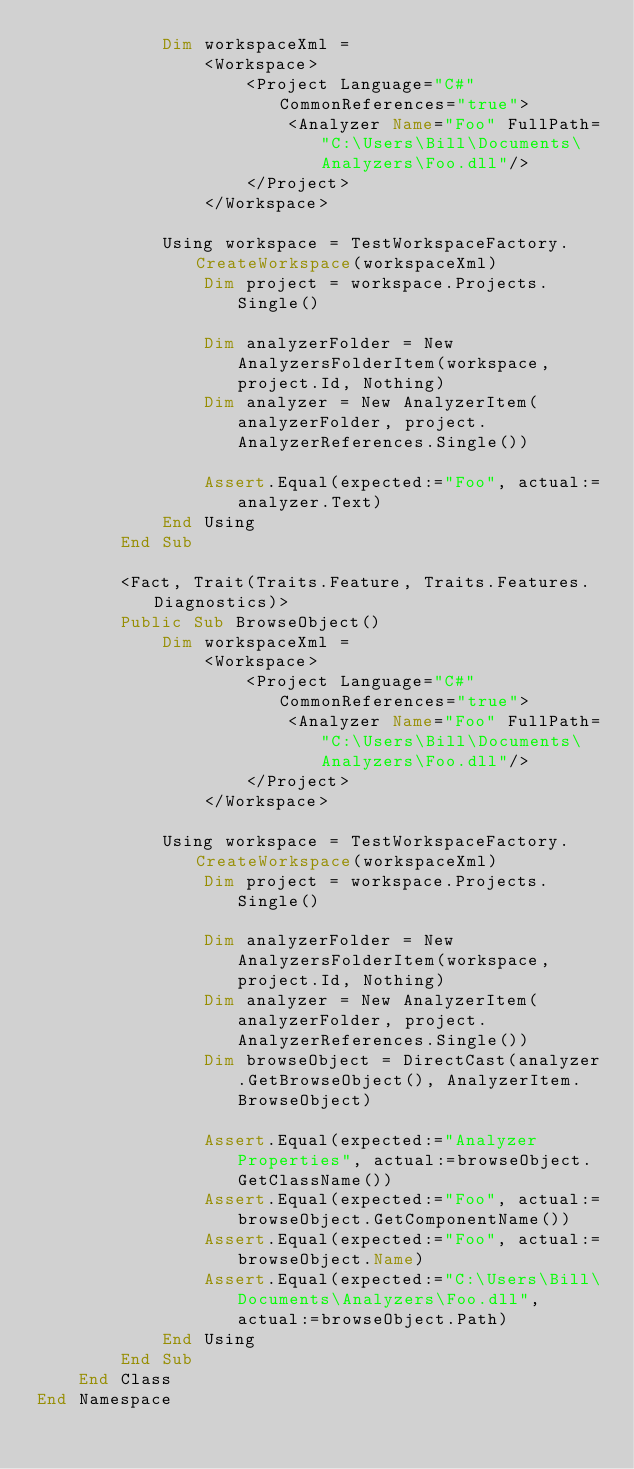Convert code to text. <code><loc_0><loc_0><loc_500><loc_500><_VisualBasic_>            Dim workspaceXml =
                <Workspace>
                    <Project Language="C#" CommonReferences="true">
                        <Analyzer Name="Foo" FullPath="C:\Users\Bill\Documents\Analyzers\Foo.dll"/>
                    </Project>
                </Workspace>

            Using workspace = TestWorkspaceFactory.CreateWorkspace(workspaceXml)
                Dim project = workspace.Projects.Single()

                Dim analyzerFolder = New AnalyzersFolderItem(workspace, project.Id, Nothing)
                Dim analyzer = New AnalyzerItem(analyzerFolder, project.AnalyzerReferences.Single())

                Assert.Equal(expected:="Foo", actual:=analyzer.Text)
            End Using
        End Sub

        <Fact, Trait(Traits.Feature, Traits.Features.Diagnostics)>
        Public Sub BrowseObject()
            Dim workspaceXml =
                <Workspace>
                    <Project Language="C#" CommonReferences="true">
                        <Analyzer Name="Foo" FullPath="C:\Users\Bill\Documents\Analyzers\Foo.dll"/>
                    </Project>
                </Workspace>

            Using workspace = TestWorkspaceFactory.CreateWorkspace(workspaceXml)
                Dim project = workspace.Projects.Single()

                Dim analyzerFolder = New AnalyzersFolderItem(workspace, project.Id, Nothing)
                Dim analyzer = New AnalyzerItem(analyzerFolder, project.AnalyzerReferences.Single())
                Dim browseObject = DirectCast(analyzer.GetBrowseObject(), AnalyzerItem.BrowseObject)

                Assert.Equal(expected:="Analyzer Properties", actual:=browseObject.GetClassName())
                Assert.Equal(expected:="Foo", actual:=browseObject.GetComponentName())
                Assert.Equal(expected:="Foo", actual:=browseObject.Name)
                Assert.Equal(expected:="C:\Users\Bill\Documents\Analyzers\Foo.dll", actual:=browseObject.Path)
            End Using
        End Sub
    End Class
End Namespace
</code> 